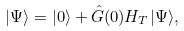<formula> <loc_0><loc_0><loc_500><loc_500>| \Psi \rangle = | 0 \rangle + \hat { G } ( 0 ) H _ { T } | \Psi \rangle ,</formula> 